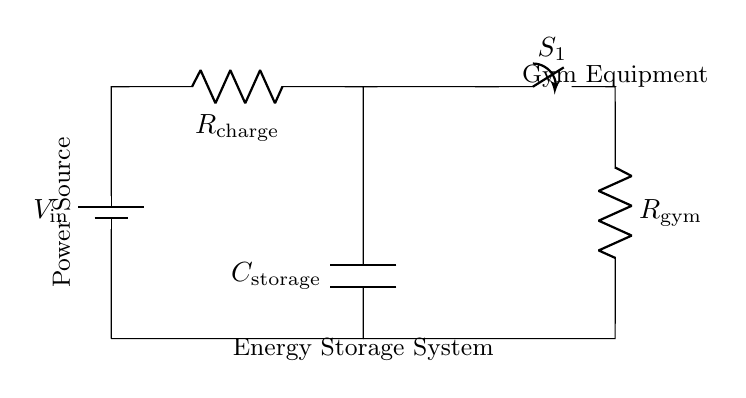What is the component labeled as \(C_\text{storage}\)? The component \(C_\text{storage}\) in the circuit diagram represents a capacitor, which is used for energy storage.
Answer: Capacitor What is the purpose of the switch labeled \(S_1\)? The switch \(S_1\) controls the connection between the energy storage system and the gym equipment, allowing or disconnecting the flow of power.
Answer: Control What does the resistor \(R_\text{gym}\) represent? The resistor \(R_\text{gym}\) represents the load of the gym equipment, which consumes power when connected to the energy storage system.
Answer: Load What happens when the switch \(S_1\) is closed? When \(S_1\) is closed, the circuit completes and allows the stored energy from the capacitor to flow to the gym equipment, providing it with power.
Answer: Powers equipment Why is the capacitor used in this circuit? The capacitor is used to store electrical energy temporarily so that it can be released as needed to power gym equipment during outages or high demand.
Answer: Energy storage What would happen if the resistor \(R_\text{charge}\) were removed? If \(R_\text{charge}\) were removed, the charging current might be too high, potentially damaging the capacitor or the power source, as there would be no limit on the current flow.
Answer: Damage risk How does current flow when the system is charging? During charging, the current flows from the power source through the resistor \(R_\text{charge}\) into the capacitor, storing energy until needed by the gym equipment when the switch \(S_1\) is closed.
Answer: Flows to capacitor 